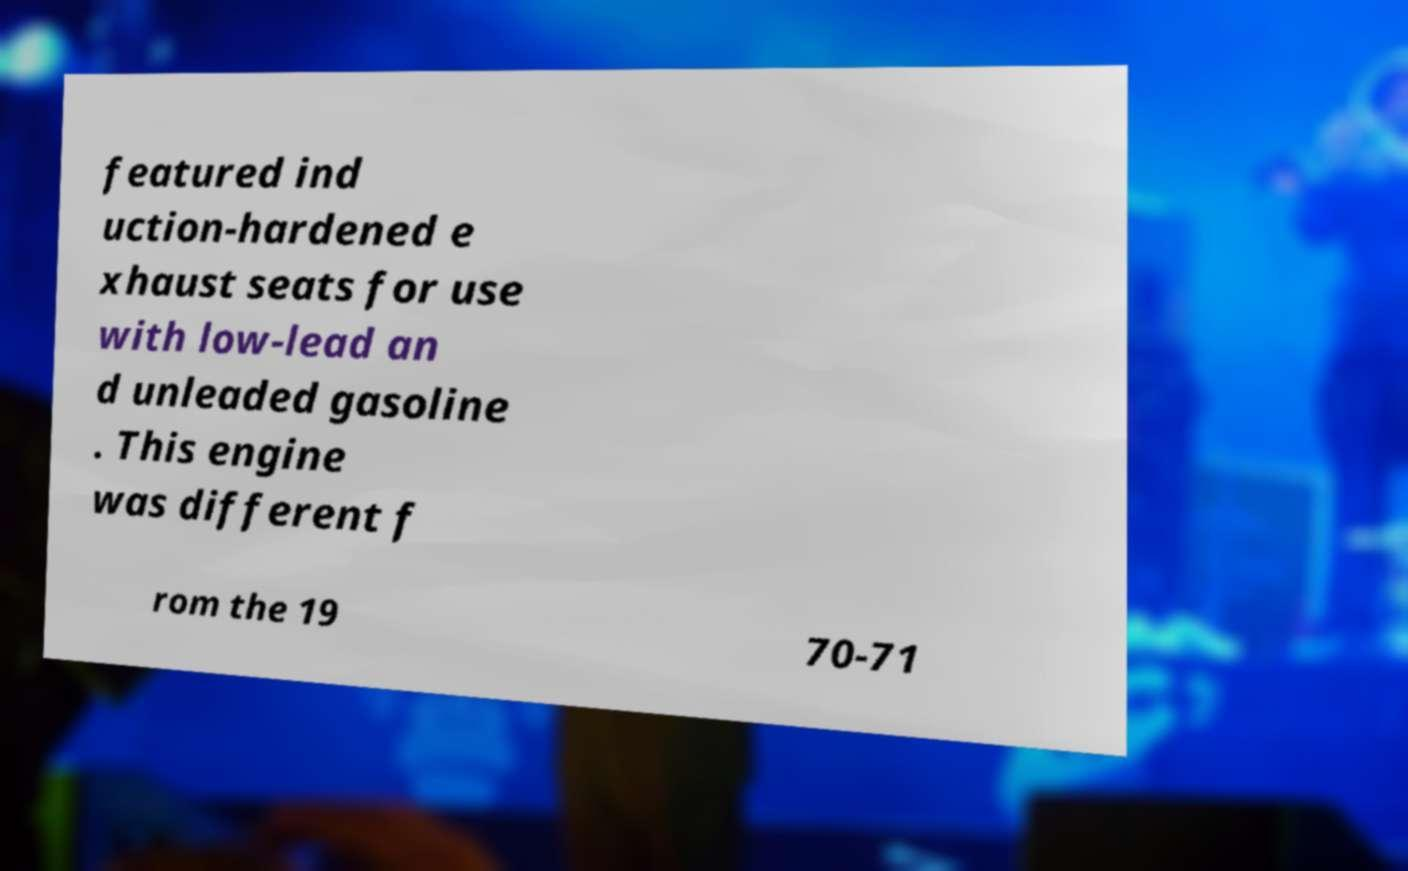Please identify and transcribe the text found in this image. featured ind uction-hardened e xhaust seats for use with low-lead an d unleaded gasoline . This engine was different f rom the 19 70-71 